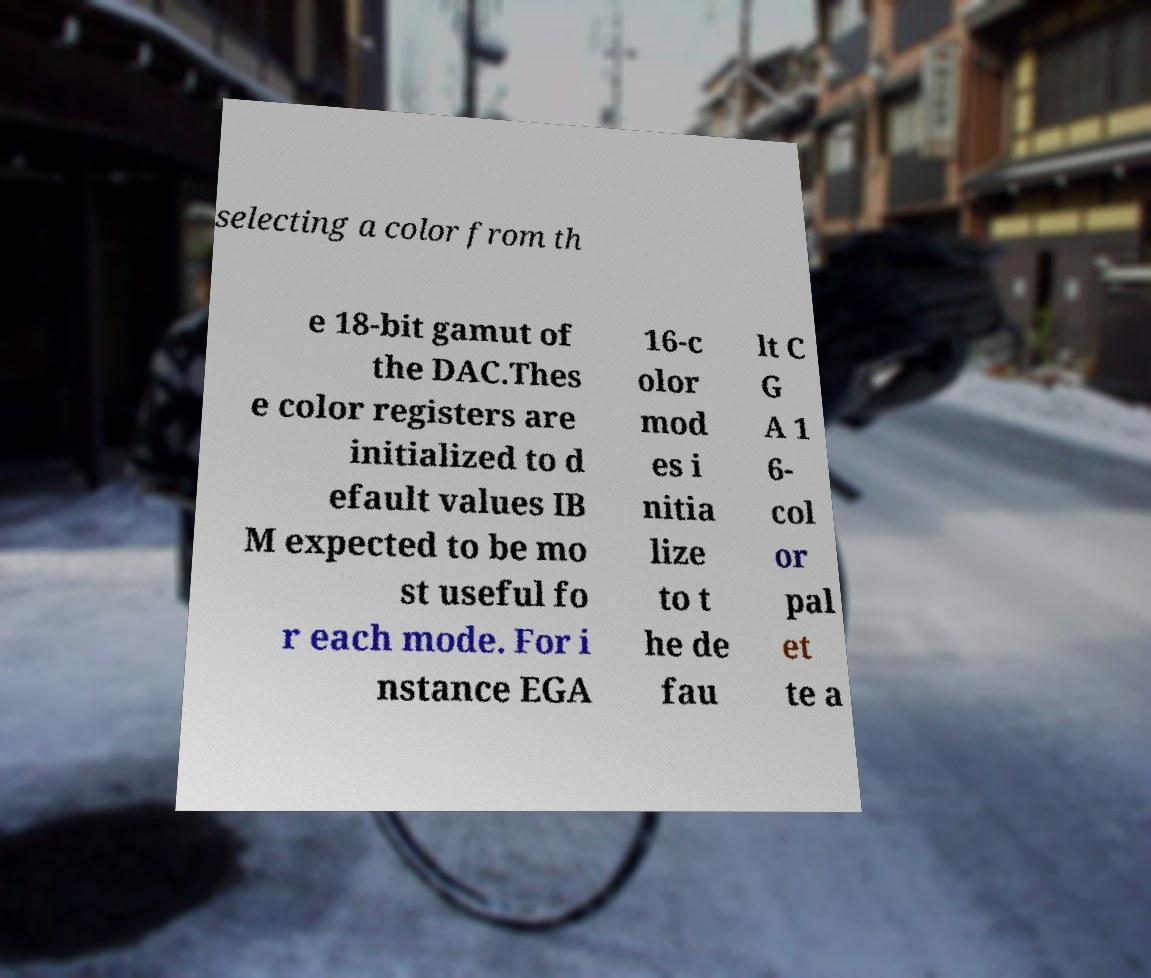What messages or text are displayed in this image? I need them in a readable, typed format. selecting a color from th e 18-bit gamut of the DAC.Thes e color registers are initialized to d efault values IB M expected to be mo st useful fo r each mode. For i nstance EGA 16-c olor mod es i nitia lize to t he de fau lt C G A 1 6- col or pal et te a 